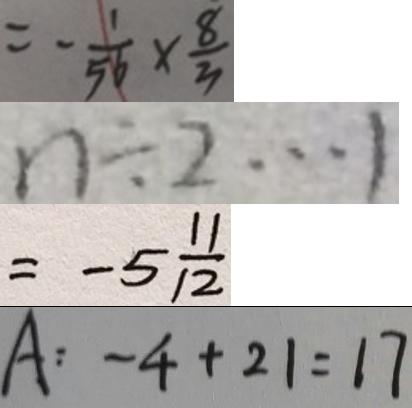<formula> <loc_0><loc_0><loc_500><loc_500>= - \frac { 1 } { 5 6 } \times \frac { 8 } { 3 } 
 n \div 2 \cdots 1 
 = - 5 \frac { 1 1 } { 1 2 } 
 A : - 4 + 2 1 = 1 7</formula> 